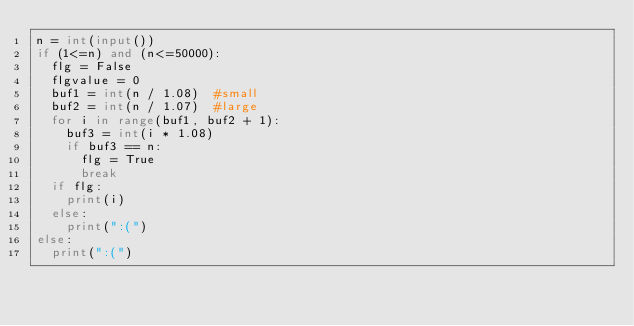<code> <loc_0><loc_0><loc_500><loc_500><_Python_>n = int(input())
if (1<=n) and (n<=50000):
  flg = False
  flgvalue = 0
  buf1 = int(n / 1.08)	#small
  buf2 = int(n / 1.07)	#large
  for i in range(buf1, buf2 + 1):
    buf3 = int(i * 1.08)
    if buf3 == n:
      flg = True
      break
  if flg:
    print(i)
  else:
    print(":(")
else:
  print(":(")</code> 